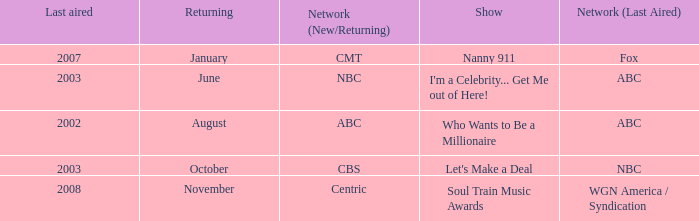When did soul train music awards return? November. 